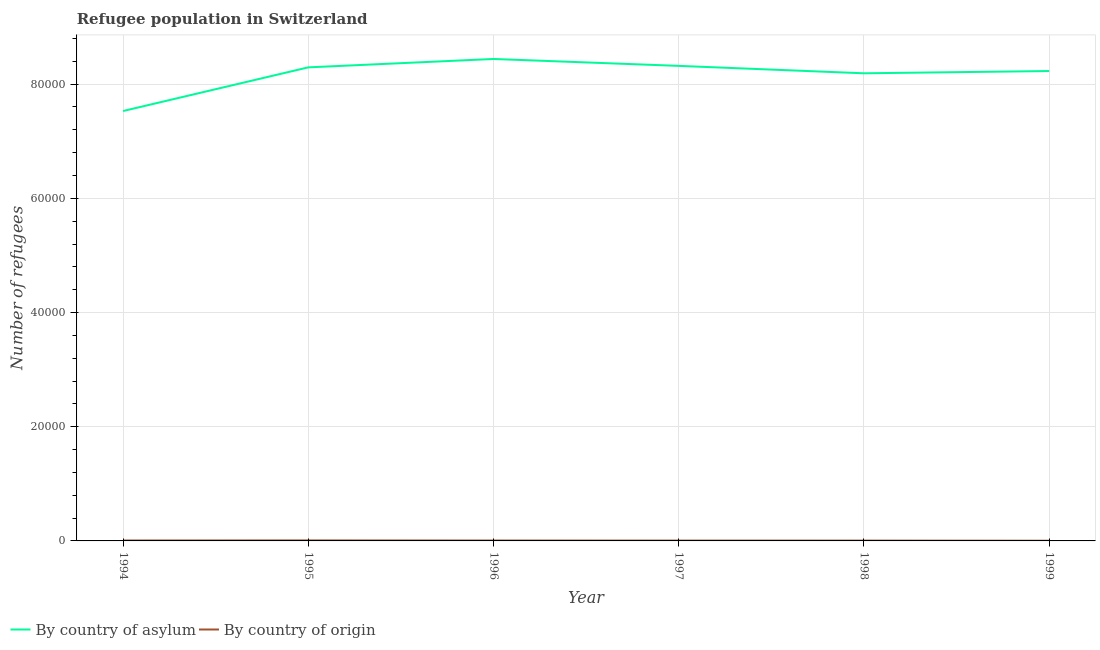Is the number of lines equal to the number of legend labels?
Your answer should be compact. Yes. What is the number of refugees by country of origin in 1997?
Keep it short and to the point. 61. Across all years, what is the maximum number of refugees by country of origin?
Ensure brevity in your answer.  91. Across all years, what is the minimum number of refugees by country of asylum?
Your answer should be very brief. 7.53e+04. In which year was the number of refugees by country of origin maximum?
Your answer should be very brief. 1995. In which year was the number of refugees by country of origin minimum?
Keep it short and to the point. 1999. What is the total number of refugees by country of origin in the graph?
Offer a very short reply. 390. What is the difference between the number of refugees by country of origin in 1995 and that in 1999?
Provide a succinct answer. 56. What is the difference between the number of refugees by country of asylum in 1997 and the number of refugees by country of origin in 1999?
Keep it short and to the point. 8.32e+04. What is the average number of refugees by country of asylum per year?
Offer a very short reply. 8.17e+04. In the year 1999, what is the difference between the number of refugees by country of asylum and number of refugees by country of origin?
Keep it short and to the point. 8.23e+04. What is the ratio of the number of refugees by country of asylum in 1995 to that in 1998?
Provide a short and direct response. 1.01. Is the difference between the number of refugees by country of asylum in 1994 and 1995 greater than the difference between the number of refugees by country of origin in 1994 and 1995?
Your answer should be compact. No. What is the difference between the highest and the lowest number of refugees by country of origin?
Offer a very short reply. 56. In how many years, is the number of refugees by country of origin greater than the average number of refugees by country of origin taken over all years?
Provide a short and direct response. 3. Is the sum of the number of refugees by country of asylum in 1996 and 1998 greater than the maximum number of refugees by country of origin across all years?
Provide a short and direct response. Yes. Does the number of refugees by country of asylum monotonically increase over the years?
Your answer should be compact. No. How many lines are there?
Make the answer very short. 2. How many years are there in the graph?
Your answer should be very brief. 6. What is the difference between two consecutive major ticks on the Y-axis?
Ensure brevity in your answer.  2.00e+04. Does the graph contain grids?
Offer a terse response. Yes. Where does the legend appear in the graph?
Your answer should be compact. Bottom left. How are the legend labels stacked?
Offer a terse response. Horizontal. What is the title of the graph?
Your answer should be compact. Refugee population in Switzerland. What is the label or title of the Y-axis?
Offer a terse response. Number of refugees. What is the Number of refugees of By country of asylum in 1994?
Provide a short and direct response. 7.53e+04. What is the Number of refugees of By country of asylum in 1995?
Your response must be concise. 8.29e+04. What is the Number of refugees in By country of origin in 1995?
Ensure brevity in your answer.  91. What is the Number of refugees in By country of asylum in 1996?
Offer a very short reply. 8.44e+04. What is the Number of refugees of By country of asylum in 1997?
Offer a very short reply. 8.32e+04. What is the Number of refugees of By country of asylum in 1998?
Your response must be concise. 8.19e+04. What is the Number of refugees in By country of asylum in 1999?
Keep it short and to the point. 8.23e+04. What is the Number of refugees in By country of origin in 1999?
Your answer should be compact. 35. Across all years, what is the maximum Number of refugees in By country of asylum?
Your response must be concise. 8.44e+04. Across all years, what is the maximum Number of refugees of By country of origin?
Your answer should be compact. 91. Across all years, what is the minimum Number of refugees of By country of asylum?
Provide a succinct answer. 7.53e+04. What is the total Number of refugees in By country of asylum in the graph?
Provide a short and direct response. 4.90e+05. What is the total Number of refugees of By country of origin in the graph?
Offer a terse response. 390. What is the difference between the Number of refugees in By country of asylum in 1994 and that in 1995?
Your answer should be compact. -7648. What is the difference between the Number of refugees in By country of asylum in 1994 and that in 1996?
Offer a very short reply. -9118. What is the difference between the Number of refugees in By country of origin in 1994 and that in 1996?
Offer a terse response. 7. What is the difference between the Number of refugees of By country of asylum in 1994 and that in 1997?
Give a very brief answer. -7908. What is the difference between the Number of refugees of By country of asylum in 1994 and that in 1998?
Your answer should be compact. -6608. What is the difference between the Number of refugees in By country of asylum in 1994 and that in 1999?
Give a very brief answer. -7003. What is the difference between the Number of refugees in By country of origin in 1994 and that in 1999?
Your response must be concise. 42. What is the difference between the Number of refugees of By country of asylum in 1995 and that in 1996?
Make the answer very short. -1470. What is the difference between the Number of refugees of By country of origin in 1995 and that in 1996?
Provide a succinct answer. 21. What is the difference between the Number of refugees in By country of asylum in 1995 and that in 1997?
Give a very brief answer. -260. What is the difference between the Number of refugees in By country of origin in 1995 and that in 1997?
Offer a terse response. 30. What is the difference between the Number of refugees of By country of asylum in 1995 and that in 1998?
Keep it short and to the point. 1040. What is the difference between the Number of refugees of By country of asylum in 1995 and that in 1999?
Provide a short and direct response. 645. What is the difference between the Number of refugees of By country of asylum in 1996 and that in 1997?
Make the answer very short. 1210. What is the difference between the Number of refugees of By country of origin in 1996 and that in 1997?
Your response must be concise. 9. What is the difference between the Number of refugees of By country of asylum in 1996 and that in 1998?
Ensure brevity in your answer.  2510. What is the difference between the Number of refugees of By country of asylum in 1996 and that in 1999?
Ensure brevity in your answer.  2115. What is the difference between the Number of refugees of By country of asylum in 1997 and that in 1998?
Your response must be concise. 1300. What is the difference between the Number of refugees in By country of asylum in 1997 and that in 1999?
Keep it short and to the point. 905. What is the difference between the Number of refugees in By country of origin in 1997 and that in 1999?
Provide a short and direct response. 26. What is the difference between the Number of refugees in By country of asylum in 1998 and that in 1999?
Make the answer very short. -395. What is the difference between the Number of refugees in By country of asylum in 1994 and the Number of refugees in By country of origin in 1995?
Your answer should be very brief. 7.52e+04. What is the difference between the Number of refugees of By country of asylum in 1994 and the Number of refugees of By country of origin in 1996?
Offer a very short reply. 7.52e+04. What is the difference between the Number of refugees of By country of asylum in 1994 and the Number of refugees of By country of origin in 1997?
Your answer should be very brief. 7.52e+04. What is the difference between the Number of refugees in By country of asylum in 1994 and the Number of refugees in By country of origin in 1998?
Your answer should be very brief. 7.52e+04. What is the difference between the Number of refugees of By country of asylum in 1994 and the Number of refugees of By country of origin in 1999?
Ensure brevity in your answer.  7.53e+04. What is the difference between the Number of refugees of By country of asylum in 1995 and the Number of refugees of By country of origin in 1996?
Provide a succinct answer. 8.29e+04. What is the difference between the Number of refugees of By country of asylum in 1995 and the Number of refugees of By country of origin in 1997?
Make the answer very short. 8.29e+04. What is the difference between the Number of refugees of By country of asylum in 1995 and the Number of refugees of By country of origin in 1998?
Offer a very short reply. 8.29e+04. What is the difference between the Number of refugees in By country of asylum in 1995 and the Number of refugees in By country of origin in 1999?
Your answer should be compact. 8.29e+04. What is the difference between the Number of refugees of By country of asylum in 1996 and the Number of refugees of By country of origin in 1997?
Ensure brevity in your answer.  8.44e+04. What is the difference between the Number of refugees of By country of asylum in 1996 and the Number of refugees of By country of origin in 1998?
Your answer should be compact. 8.44e+04. What is the difference between the Number of refugees in By country of asylum in 1996 and the Number of refugees in By country of origin in 1999?
Your answer should be compact. 8.44e+04. What is the difference between the Number of refugees in By country of asylum in 1997 and the Number of refugees in By country of origin in 1998?
Keep it short and to the point. 8.31e+04. What is the difference between the Number of refugees in By country of asylum in 1997 and the Number of refugees in By country of origin in 1999?
Ensure brevity in your answer.  8.32e+04. What is the difference between the Number of refugees of By country of asylum in 1998 and the Number of refugees of By country of origin in 1999?
Keep it short and to the point. 8.19e+04. What is the average Number of refugees of By country of asylum per year?
Provide a succinct answer. 8.17e+04. What is the average Number of refugees of By country of origin per year?
Provide a succinct answer. 65. In the year 1994, what is the difference between the Number of refugees in By country of asylum and Number of refugees in By country of origin?
Make the answer very short. 7.52e+04. In the year 1995, what is the difference between the Number of refugees of By country of asylum and Number of refugees of By country of origin?
Provide a succinct answer. 8.29e+04. In the year 1996, what is the difference between the Number of refugees in By country of asylum and Number of refugees in By country of origin?
Give a very brief answer. 8.43e+04. In the year 1997, what is the difference between the Number of refugees of By country of asylum and Number of refugees of By country of origin?
Offer a very short reply. 8.31e+04. In the year 1998, what is the difference between the Number of refugees of By country of asylum and Number of refugees of By country of origin?
Offer a very short reply. 8.18e+04. In the year 1999, what is the difference between the Number of refugees in By country of asylum and Number of refugees in By country of origin?
Your answer should be compact. 8.23e+04. What is the ratio of the Number of refugees of By country of asylum in 1994 to that in 1995?
Provide a short and direct response. 0.91. What is the ratio of the Number of refugees of By country of origin in 1994 to that in 1995?
Your answer should be very brief. 0.85. What is the ratio of the Number of refugees in By country of asylum in 1994 to that in 1996?
Provide a succinct answer. 0.89. What is the ratio of the Number of refugees in By country of asylum in 1994 to that in 1997?
Your answer should be very brief. 0.91. What is the ratio of the Number of refugees of By country of origin in 1994 to that in 1997?
Your answer should be compact. 1.26. What is the ratio of the Number of refugees in By country of asylum in 1994 to that in 1998?
Your answer should be compact. 0.92. What is the ratio of the Number of refugees of By country of origin in 1994 to that in 1998?
Ensure brevity in your answer.  1.38. What is the ratio of the Number of refugees of By country of asylum in 1994 to that in 1999?
Give a very brief answer. 0.91. What is the ratio of the Number of refugees in By country of asylum in 1995 to that in 1996?
Offer a very short reply. 0.98. What is the ratio of the Number of refugees of By country of asylum in 1995 to that in 1997?
Provide a succinct answer. 1. What is the ratio of the Number of refugees in By country of origin in 1995 to that in 1997?
Keep it short and to the point. 1.49. What is the ratio of the Number of refugees of By country of asylum in 1995 to that in 1998?
Your answer should be compact. 1.01. What is the ratio of the Number of refugees of By country of origin in 1995 to that in 1998?
Provide a succinct answer. 1.62. What is the ratio of the Number of refugees of By country of origin in 1995 to that in 1999?
Provide a short and direct response. 2.6. What is the ratio of the Number of refugees of By country of asylum in 1996 to that in 1997?
Provide a succinct answer. 1.01. What is the ratio of the Number of refugees in By country of origin in 1996 to that in 1997?
Ensure brevity in your answer.  1.15. What is the ratio of the Number of refugees in By country of asylum in 1996 to that in 1998?
Your answer should be very brief. 1.03. What is the ratio of the Number of refugees of By country of asylum in 1996 to that in 1999?
Your response must be concise. 1.03. What is the ratio of the Number of refugees in By country of asylum in 1997 to that in 1998?
Ensure brevity in your answer.  1.02. What is the ratio of the Number of refugees in By country of origin in 1997 to that in 1998?
Make the answer very short. 1.09. What is the ratio of the Number of refugees of By country of asylum in 1997 to that in 1999?
Offer a very short reply. 1.01. What is the ratio of the Number of refugees in By country of origin in 1997 to that in 1999?
Your answer should be very brief. 1.74. What is the ratio of the Number of refugees in By country of origin in 1998 to that in 1999?
Your response must be concise. 1.6. What is the difference between the highest and the second highest Number of refugees of By country of asylum?
Your answer should be very brief. 1210. What is the difference between the highest and the lowest Number of refugees in By country of asylum?
Your answer should be very brief. 9118. What is the difference between the highest and the lowest Number of refugees in By country of origin?
Make the answer very short. 56. 